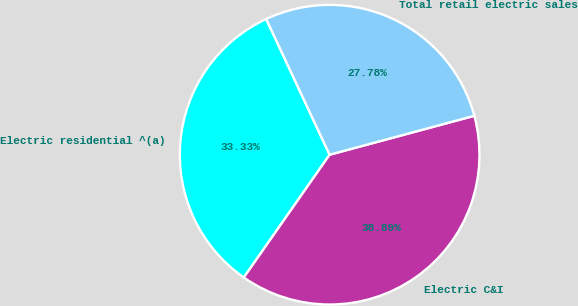<chart> <loc_0><loc_0><loc_500><loc_500><pie_chart><fcel>Electric residential ^(a)<fcel>Electric C&I<fcel>Total retail electric sales<nl><fcel>33.33%<fcel>38.89%<fcel>27.78%<nl></chart> 